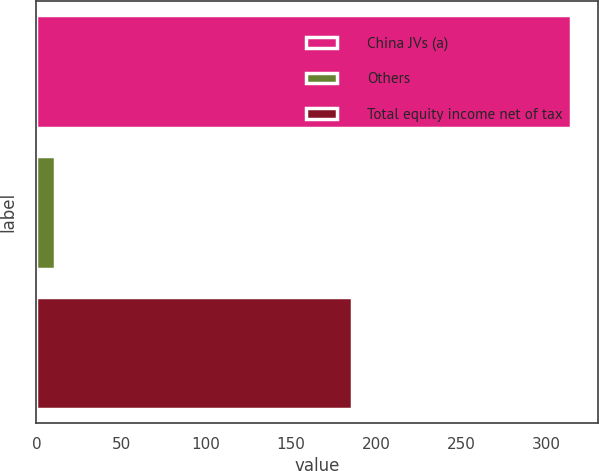Convert chart. <chart><loc_0><loc_0><loc_500><loc_500><bar_chart><fcel>China JVs (a)<fcel>Others<fcel>Total equity income net of tax<nl><fcel>315<fcel>11<fcel>186<nl></chart> 